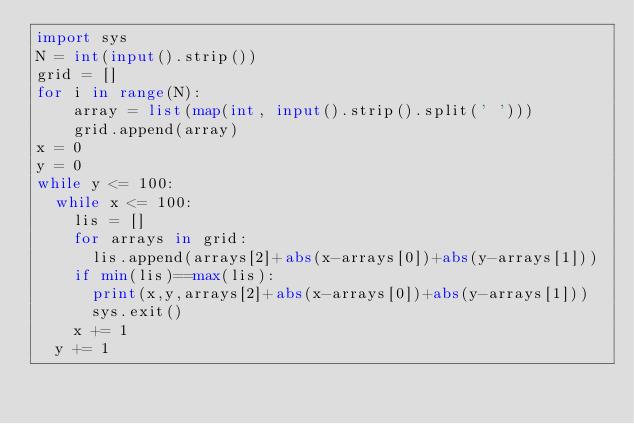Convert code to text. <code><loc_0><loc_0><loc_500><loc_500><_Python_>import sys
N = int(input().strip())
grid = []
for i in range(N):
    array = list(map(int, input().strip().split(' ')))
    grid.append(array)
x = 0
y = 0
while y <= 100:
  while x <= 100:
    lis = []
    for arrays in grid:
      lis.append(arrays[2]+abs(x-arrays[0])+abs(y-arrays[1]))
    if min(lis)==max(lis):
      print(x,y,arrays[2]+abs(x-arrays[0])+abs(y-arrays[1]))
      sys.exit()
    x += 1
  y += 1
        
</code> 